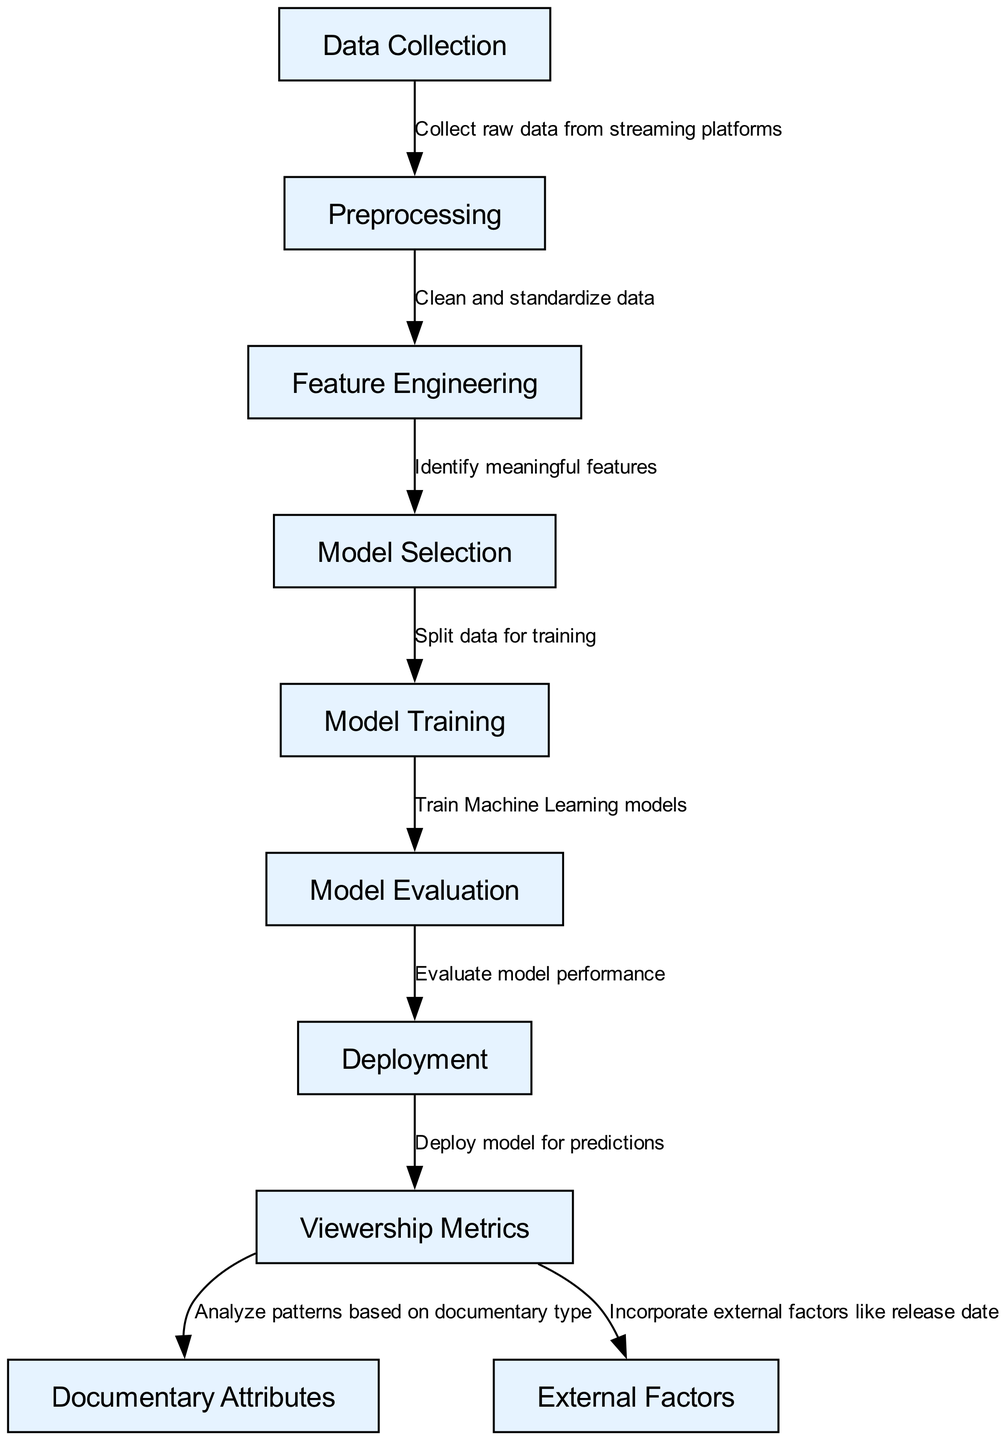What are the nodes in the diagram? The nodes in the diagram are: Data Collection, Preprocessing, Feature Engineering, Model Selection, Model Training, Model Evaluation, Deployment, Viewership Metrics, Documentary Attributes, and External Factors. This is derived from the "nodes" section of the diagram data.
Answer: Data Collection, Preprocessing, Feature Engineering, Model Selection, Model Training, Model Evaluation, Deployment, Viewership Metrics, Documentary Attributes, External Factors How many nodes are there? By counting the entries in the "nodes" section of the diagram data, there are a total of ten nodes listed.
Answer: Ten What is the label on the edge from Model Training to Model Evaluation? The edge label from Model Training to Model Evaluation indicates the action that occurs between these nodes. According to the diagram, the label is "Train Machine Learning models."
Answer: Train Machine Learning models What do Viewership Metrics analyze based on? The diagram shows that Viewership Metrics analyze patterns based on documentary type, as indicated by the directed edge leading from Viewership Metrics to Documentary Attributes.
Answer: Documentary type What is the first step in the machine learning process illustrated in the diagram? The first node in the machine learning process, as indicated by the starting point of the diagram, is "Data Collection." This is the initial step in gathering necessary data for analysis.
Answer: Data Collection What is the last step before deploying the model? To find this, we can trace back from the Deployment node. The last step indicated before Deployment is "Model Evaluation", where the performance of the model is assessed.
Answer: Model Evaluation How many edges are present in the diagram? By examining the "edges" section, we can count that there are a total of eight edges connecting the nodes in the diagram.
Answer: Eight Which node incorporates external factors? The node that incorporates external factors is "Viewership Metrics," as it is connected to the External Factors node based on the information in the edges.
Answer: Viewership Metrics 